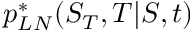Convert formula to latex. <formula><loc_0><loc_0><loc_500><loc_500>p _ { L N } ^ { * } ( S _ { T } , T | S , t )</formula> 